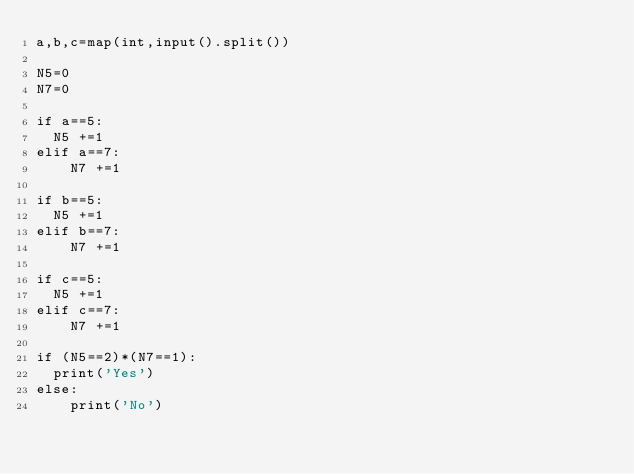Convert code to text. <code><loc_0><loc_0><loc_500><loc_500><_Python_>a,b,c=map(int,input().split())

N5=0
N7=0

if a==5:
  N5 +=1
elif a==7:
    N7 +=1

if b==5:
  N5 +=1
elif b==7:
    N7 +=1
    
if c==5:
  N5 +=1
elif c==7:
    N7 +=1
    
if (N5==2)*(N7==1):
  print('Yes')
else:
    print('No')</code> 